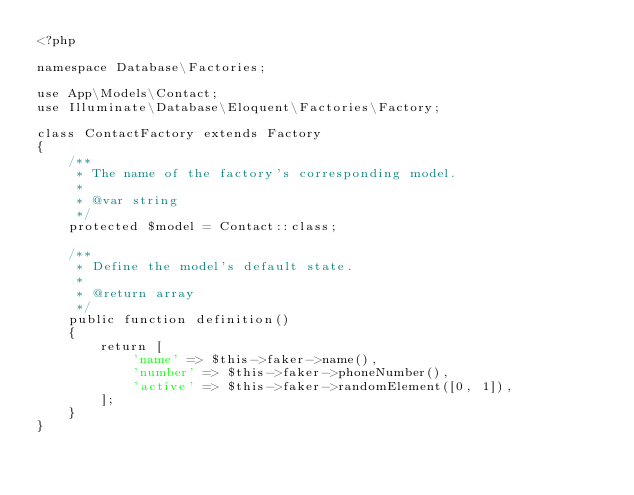<code> <loc_0><loc_0><loc_500><loc_500><_PHP_><?php

namespace Database\Factories;

use App\Models\Contact;
use Illuminate\Database\Eloquent\Factories\Factory;

class ContactFactory extends Factory
{
    /**
     * The name of the factory's corresponding model.
     *
     * @var string
     */
    protected $model = Contact::class;

    /**
     * Define the model's default state.
     *
     * @return array
     */
    public function definition()
    {
        return [
            'name' => $this->faker->name(),
            'number' => $this->faker->phoneNumber(),
            'active' => $this->faker->randomElement([0, 1]),
        ];
    }
}
</code> 